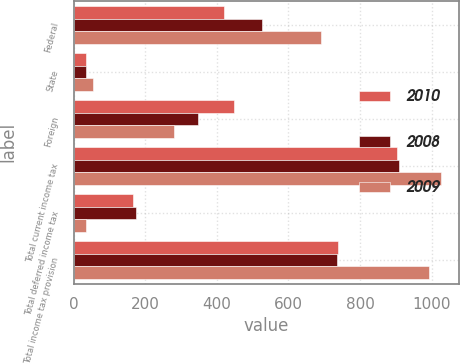<chart> <loc_0><loc_0><loc_500><loc_500><stacked_bar_chart><ecel><fcel>Federal<fcel>State<fcel>Foreign<fcel>Total current income tax<fcel>Total deferred income tax<fcel>Total income tax provision<nl><fcel>2010<fcel>421<fcel>34<fcel>448<fcel>903<fcel>165<fcel>738<nl><fcel>2008<fcel>526<fcel>35<fcel>348<fcel>909<fcel>174<fcel>735<nl><fcel>2009<fcel>691<fcel>55<fcel>280<fcel>1026<fcel>33<fcel>993<nl></chart> 